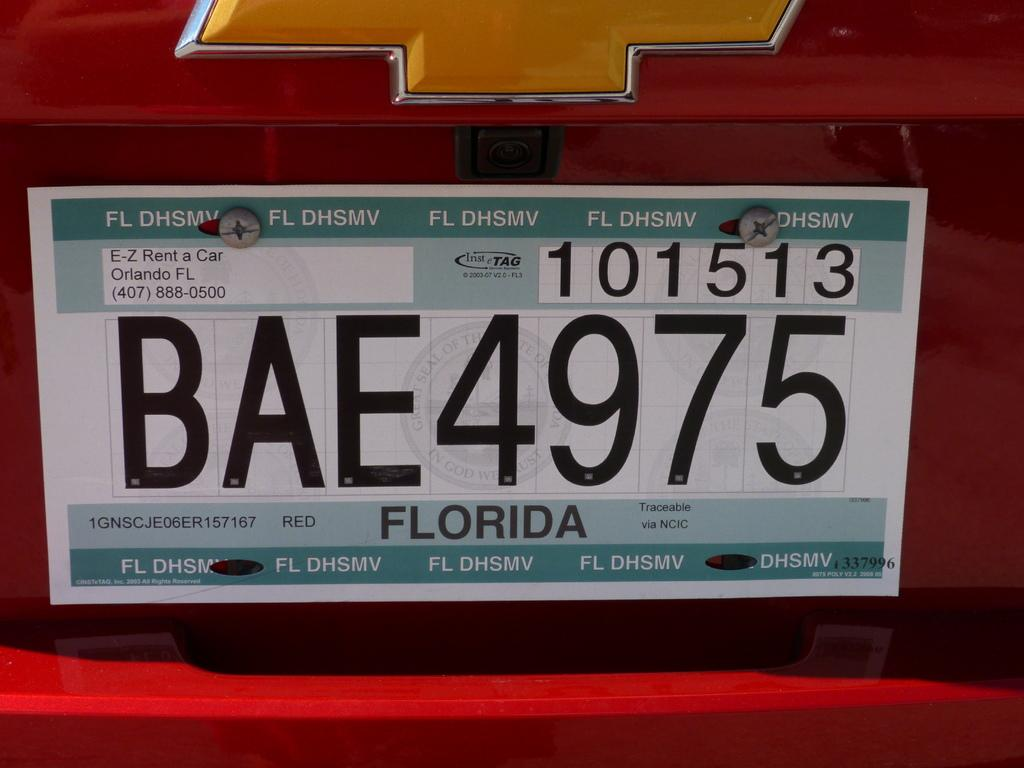<image>
Present a compact description of the photo's key features. a FLORIDA license plate on a red car with BAE4975 on it. 